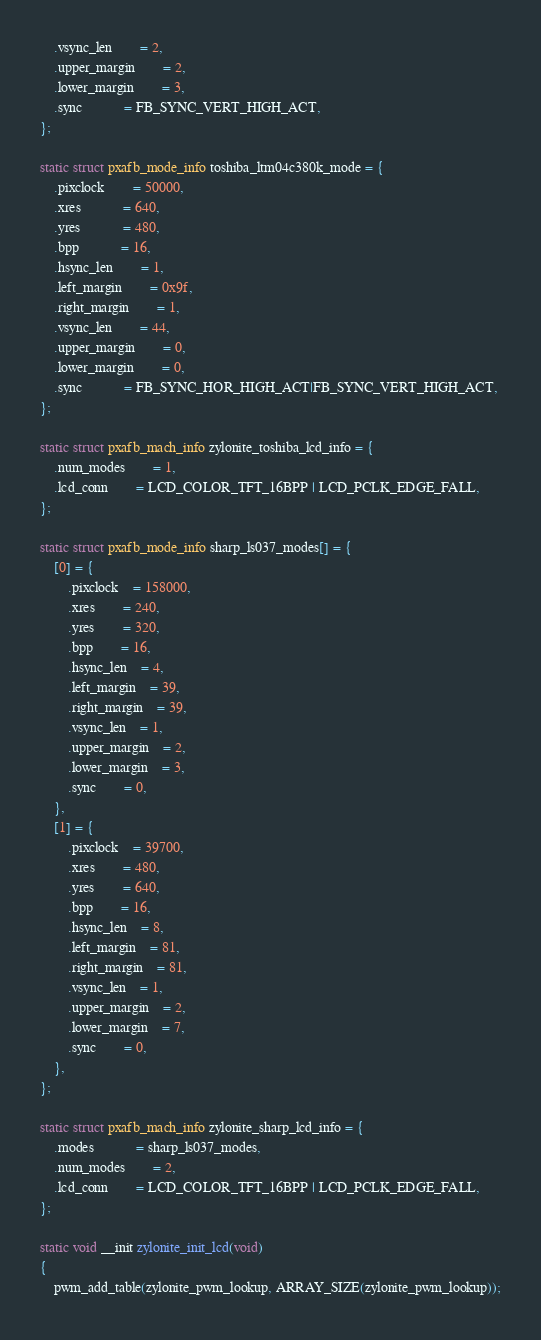<code> <loc_0><loc_0><loc_500><loc_500><_C_>	.vsync_len		= 2,
	.upper_margin		= 2,
	.lower_margin		= 3,
	.sync			= FB_SYNC_VERT_HIGH_ACT,
};

static struct pxafb_mode_info toshiba_ltm04c380k_mode = {
	.pixclock		= 50000,
	.xres			= 640,
	.yres			= 480,
	.bpp			= 16,
	.hsync_len		= 1,
	.left_margin		= 0x9f,
	.right_margin		= 1,
	.vsync_len		= 44,
	.upper_margin		= 0,
	.lower_margin		= 0,
	.sync			= FB_SYNC_HOR_HIGH_ACT|FB_SYNC_VERT_HIGH_ACT,
};

static struct pxafb_mach_info zylonite_toshiba_lcd_info = {
	.num_modes      	= 1,
	.lcd_conn		= LCD_COLOR_TFT_16BPP | LCD_PCLK_EDGE_FALL,
};

static struct pxafb_mode_info sharp_ls037_modes[] = {
	[0] = {
		.pixclock	= 158000,
		.xres		= 240,
		.yres		= 320,
		.bpp		= 16,
		.hsync_len	= 4,
		.left_margin	= 39,
		.right_margin	= 39,
		.vsync_len	= 1,
		.upper_margin	= 2,
		.lower_margin	= 3,
		.sync		= 0,
	},
	[1] = {
		.pixclock	= 39700,
		.xres		= 480,
		.yres		= 640,
		.bpp		= 16,
		.hsync_len	= 8,
		.left_margin	= 81,
		.right_margin	= 81,
		.vsync_len	= 1,
		.upper_margin	= 2,
		.lower_margin	= 7,
		.sync		= 0,
	},
};

static struct pxafb_mach_info zylonite_sharp_lcd_info = {
	.modes			= sharp_ls037_modes,
	.num_modes		= 2,
	.lcd_conn		= LCD_COLOR_TFT_16BPP | LCD_PCLK_EDGE_FALL,
};

static void __init zylonite_init_lcd(void)
{
	pwm_add_table(zylonite_pwm_lookup, ARRAY_SIZE(zylonite_pwm_lookup));</code> 